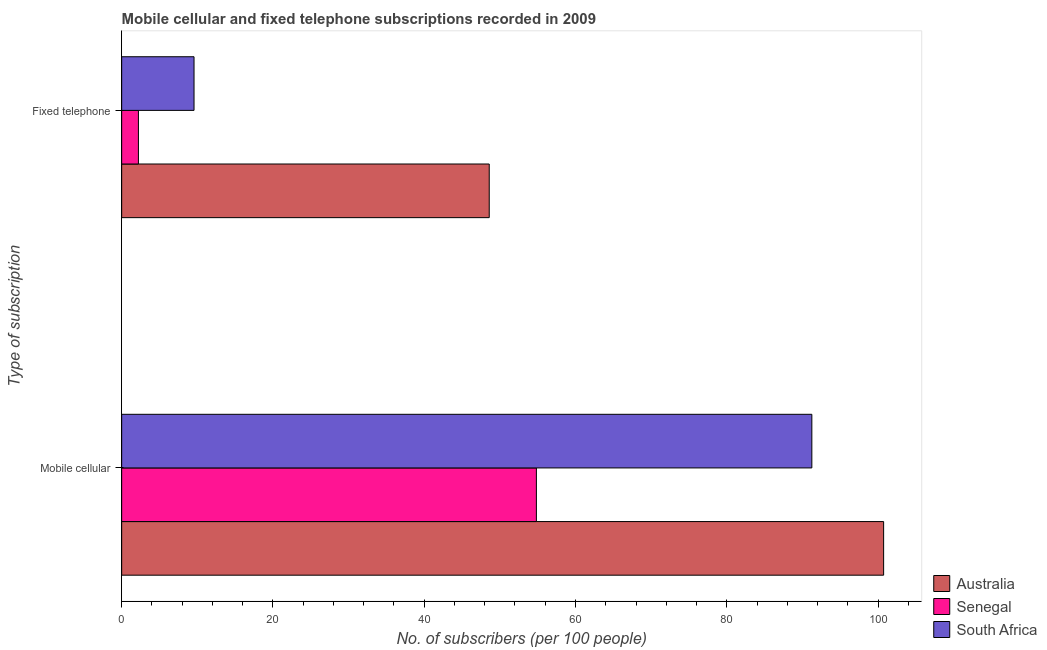How many different coloured bars are there?
Keep it short and to the point. 3. How many groups of bars are there?
Offer a terse response. 2. Are the number of bars per tick equal to the number of legend labels?
Give a very brief answer. Yes. How many bars are there on the 2nd tick from the top?
Provide a succinct answer. 3. What is the label of the 2nd group of bars from the top?
Your answer should be compact. Mobile cellular. What is the number of mobile cellular subscribers in South Africa?
Provide a short and direct response. 91.25. Across all countries, what is the maximum number of fixed telephone subscribers?
Ensure brevity in your answer.  48.6. Across all countries, what is the minimum number of fixed telephone subscribers?
Ensure brevity in your answer.  2.21. In which country was the number of fixed telephone subscribers minimum?
Ensure brevity in your answer.  Senegal. What is the total number of mobile cellular subscribers in the graph?
Offer a very short reply. 246.82. What is the difference between the number of mobile cellular subscribers in South Africa and that in Senegal?
Offer a terse response. 36.42. What is the difference between the number of mobile cellular subscribers in Senegal and the number of fixed telephone subscribers in Australia?
Offer a terse response. 6.24. What is the average number of mobile cellular subscribers per country?
Offer a very short reply. 82.27. What is the difference between the number of mobile cellular subscribers and number of fixed telephone subscribers in South Africa?
Your response must be concise. 81.68. What is the ratio of the number of mobile cellular subscribers in Senegal to that in Australia?
Your response must be concise. 0.54. Is the number of mobile cellular subscribers in Australia less than that in South Africa?
Your response must be concise. No. What does the 1st bar from the top in Fixed telephone represents?
Your response must be concise. South Africa. What does the 3rd bar from the bottom in Mobile cellular represents?
Give a very brief answer. South Africa. How many bars are there?
Provide a short and direct response. 6. Are the values on the major ticks of X-axis written in scientific E-notation?
Keep it short and to the point. No. Does the graph contain any zero values?
Give a very brief answer. No. Does the graph contain grids?
Your answer should be compact. No. How are the legend labels stacked?
Your response must be concise. Vertical. What is the title of the graph?
Ensure brevity in your answer.  Mobile cellular and fixed telephone subscriptions recorded in 2009. What is the label or title of the X-axis?
Keep it short and to the point. No. of subscribers (per 100 people). What is the label or title of the Y-axis?
Provide a succinct answer. Type of subscription. What is the No. of subscribers (per 100 people) in Australia in Mobile cellular?
Provide a succinct answer. 100.74. What is the No. of subscribers (per 100 people) in Senegal in Mobile cellular?
Your answer should be very brief. 54.83. What is the No. of subscribers (per 100 people) of South Africa in Mobile cellular?
Ensure brevity in your answer.  91.25. What is the No. of subscribers (per 100 people) in Australia in Fixed telephone?
Give a very brief answer. 48.6. What is the No. of subscribers (per 100 people) of Senegal in Fixed telephone?
Offer a very short reply. 2.21. What is the No. of subscribers (per 100 people) in South Africa in Fixed telephone?
Your answer should be compact. 9.57. Across all Type of subscription, what is the maximum No. of subscribers (per 100 people) of Australia?
Provide a short and direct response. 100.74. Across all Type of subscription, what is the maximum No. of subscribers (per 100 people) in Senegal?
Your answer should be very brief. 54.83. Across all Type of subscription, what is the maximum No. of subscribers (per 100 people) in South Africa?
Offer a terse response. 91.25. Across all Type of subscription, what is the minimum No. of subscribers (per 100 people) of Australia?
Make the answer very short. 48.6. Across all Type of subscription, what is the minimum No. of subscribers (per 100 people) in Senegal?
Offer a very short reply. 2.21. Across all Type of subscription, what is the minimum No. of subscribers (per 100 people) of South Africa?
Ensure brevity in your answer.  9.57. What is the total No. of subscribers (per 100 people) in Australia in the graph?
Offer a very short reply. 149.33. What is the total No. of subscribers (per 100 people) of Senegal in the graph?
Make the answer very short. 57.05. What is the total No. of subscribers (per 100 people) of South Africa in the graph?
Keep it short and to the point. 100.81. What is the difference between the No. of subscribers (per 100 people) in Australia in Mobile cellular and that in Fixed telephone?
Your response must be concise. 52.14. What is the difference between the No. of subscribers (per 100 people) in Senegal in Mobile cellular and that in Fixed telephone?
Provide a short and direct response. 52.62. What is the difference between the No. of subscribers (per 100 people) of South Africa in Mobile cellular and that in Fixed telephone?
Your answer should be compact. 81.68. What is the difference between the No. of subscribers (per 100 people) in Australia in Mobile cellular and the No. of subscribers (per 100 people) in Senegal in Fixed telephone?
Offer a terse response. 98.52. What is the difference between the No. of subscribers (per 100 people) in Australia in Mobile cellular and the No. of subscribers (per 100 people) in South Africa in Fixed telephone?
Your answer should be very brief. 91.17. What is the difference between the No. of subscribers (per 100 people) of Senegal in Mobile cellular and the No. of subscribers (per 100 people) of South Africa in Fixed telephone?
Your answer should be very brief. 45.27. What is the average No. of subscribers (per 100 people) of Australia per Type of subscription?
Provide a short and direct response. 74.67. What is the average No. of subscribers (per 100 people) in Senegal per Type of subscription?
Your response must be concise. 28.52. What is the average No. of subscribers (per 100 people) of South Africa per Type of subscription?
Give a very brief answer. 50.41. What is the difference between the No. of subscribers (per 100 people) of Australia and No. of subscribers (per 100 people) of Senegal in Mobile cellular?
Keep it short and to the point. 45.91. What is the difference between the No. of subscribers (per 100 people) of Australia and No. of subscribers (per 100 people) of South Africa in Mobile cellular?
Offer a very short reply. 9.49. What is the difference between the No. of subscribers (per 100 people) of Senegal and No. of subscribers (per 100 people) of South Africa in Mobile cellular?
Offer a very short reply. -36.42. What is the difference between the No. of subscribers (per 100 people) in Australia and No. of subscribers (per 100 people) in Senegal in Fixed telephone?
Your answer should be very brief. 46.38. What is the difference between the No. of subscribers (per 100 people) of Australia and No. of subscribers (per 100 people) of South Africa in Fixed telephone?
Give a very brief answer. 39.03. What is the difference between the No. of subscribers (per 100 people) of Senegal and No. of subscribers (per 100 people) of South Africa in Fixed telephone?
Your response must be concise. -7.35. What is the ratio of the No. of subscribers (per 100 people) in Australia in Mobile cellular to that in Fixed telephone?
Ensure brevity in your answer.  2.07. What is the ratio of the No. of subscribers (per 100 people) of Senegal in Mobile cellular to that in Fixed telephone?
Provide a succinct answer. 24.76. What is the ratio of the No. of subscribers (per 100 people) in South Africa in Mobile cellular to that in Fixed telephone?
Provide a succinct answer. 9.54. What is the difference between the highest and the second highest No. of subscribers (per 100 people) in Australia?
Ensure brevity in your answer.  52.14. What is the difference between the highest and the second highest No. of subscribers (per 100 people) of Senegal?
Provide a short and direct response. 52.62. What is the difference between the highest and the second highest No. of subscribers (per 100 people) of South Africa?
Keep it short and to the point. 81.68. What is the difference between the highest and the lowest No. of subscribers (per 100 people) in Australia?
Ensure brevity in your answer.  52.14. What is the difference between the highest and the lowest No. of subscribers (per 100 people) of Senegal?
Your answer should be very brief. 52.62. What is the difference between the highest and the lowest No. of subscribers (per 100 people) in South Africa?
Your response must be concise. 81.68. 